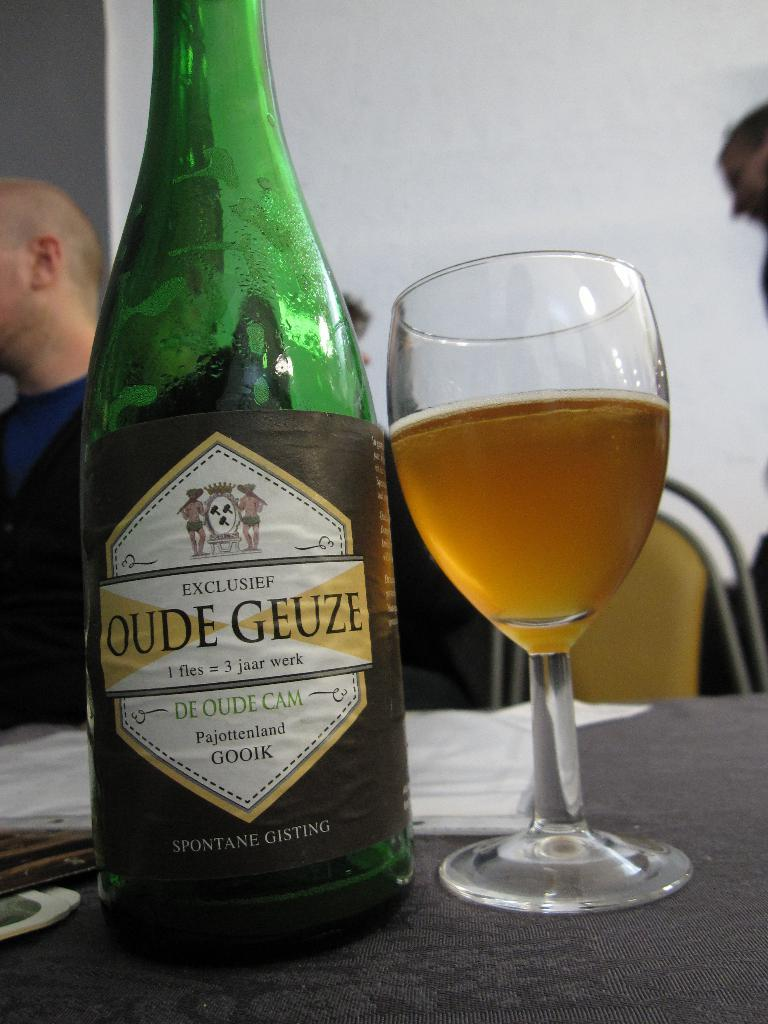<image>
Summarize the visual content of the image. the name oude geuze that is on a bottle 